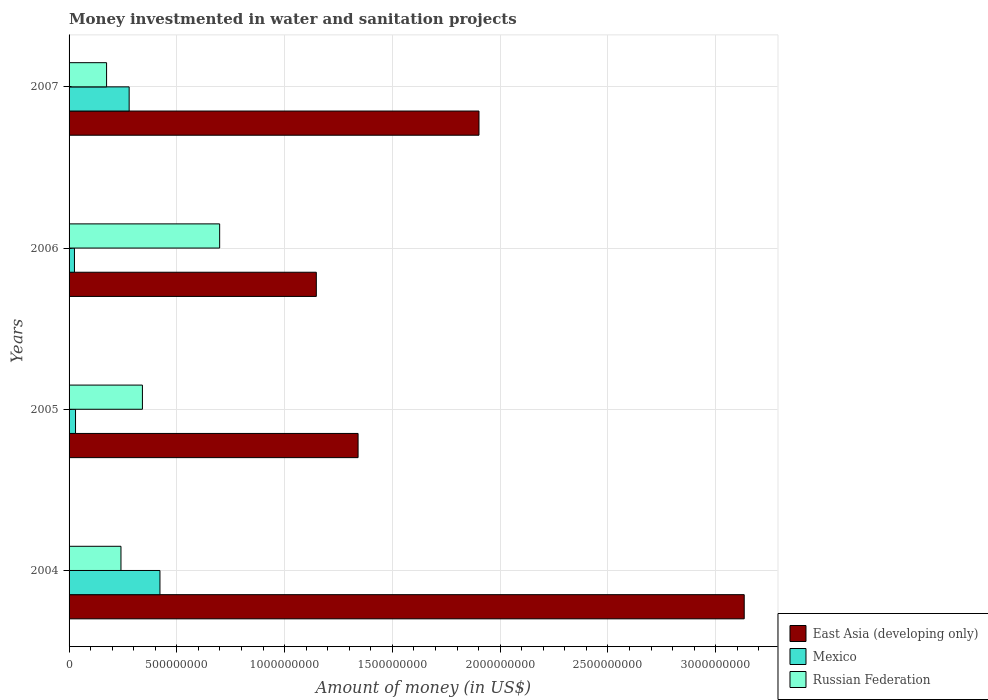How many different coloured bars are there?
Your answer should be very brief. 3. How many groups of bars are there?
Offer a very short reply. 4. How many bars are there on the 4th tick from the top?
Ensure brevity in your answer.  3. How many bars are there on the 1st tick from the bottom?
Your answer should be compact. 3. What is the money investmented in water and sanitation projects in East Asia (developing only) in 2005?
Offer a very short reply. 1.34e+09. Across all years, what is the maximum money investmented in water and sanitation projects in East Asia (developing only)?
Ensure brevity in your answer.  3.13e+09. Across all years, what is the minimum money investmented in water and sanitation projects in Mexico?
Your answer should be compact. 2.50e+07. In which year was the money investmented in water and sanitation projects in Russian Federation maximum?
Provide a succinct answer. 2006. What is the total money investmented in water and sanitation projects in Russian Federation in the graph?
Offer a very short reply. 1.45e+09. What is the difference between the money investmented in water and sanitation projects in East Asia (developing only) in 2004 and that in 2005?
Offer a very short reply. 1.79e+09. What is the difference between the money investmented in water and sanitation projects in Russian Federation in 2004 and the money investmented in water and sanitation projects in East Asia (developing only) in 2005?
Your response must be concise. -1.10e+09. What is the average money investmented in water and sanitation projects in East Asia (developing only) per year?
Provide a succinct answer. 1.88e+09. In the year 2005, what is the difference between the money investmented in water and sanitation projects in Russian Federation and money investmented in water and sanitation projects in Mexico?
Keep it short and to the point. 3.10e+08. In how many years, is the money investmented in water and sanitation projects in Mexico greater than 500000000 US$?
Offer a terse response. 0. What is the ratio of the money investmented in water and sanitation projects in East Asia (developing only) in 2005 to that in 2007?
Your response must be concise. 0.71. What is the difference between the highest and the second highest money investmented in water and sanitation projects in Mexico?
Your response must be concise. 1.43e+08. What is the difference between the highest and the lowest money investmented in water and sanitation projects in East Asia (developing only)?
Offer a very short reply. 1.99e+09. Is the sum of the money investmented in water and sanitation projects in Russian Federation in 2004 and 2007 greater than the maximum money investmented in water and sanitation projects in East Asia (developing only) across all years?
Provide a short and direct response. No. What does the 1st bar from the top in 2004 represents?
Ensure brevity in your answer.  Russian Federation. What does the 3rd bar from the bottom in 2004 represents?
Provide a succinct answer. Russian Federation. Are all the bars in the graph horizontal?
Provide a succinct answer. Yes. How many years are there in the graph?
Give a very brief answer. 4. What is the difference between two consecutive major ticks on the X-axis?
Ensure brevity in your answer.  5.00e+08. Does the graph contain any zero values?
Make the answer very short. No. Where does the legend appear in the graph?
Ensure brevity in your answer.  Bottom right. How many legend labels are there?
Make the answer very short. 3. What is the title of the graph?
Your response must be concise. Money investmented in water and sanitation projects. Does "Europe(all income levels)" appear as one of the legend labels in the graph?
Provide a succinct answer. No. What is the label or title of the X-axis?
Give a very brief answer. Amount of money (in US$). What is the label or title of the Y-axis?
Make the answer very short. Years. What is the Amount of money (in US$) of East Asia (developing only) in 2004?
Provide a short and direct response. 3.13e+09. What is the Amount of money (in US$) in Mexico in 2004?
Your response must be concise. 4.22e+08. What is the Amount of money (in US$) in Russian Federation in 2004?
Ensure brevity in your answer.  2.41e+08. What is the Amount of money (in US$) of East Asia (developing only) in 2005?
Keep it short and to the point. 1.34e+09. What is the Amount of money (in US$) of Mexico in 2005?
Provide a short and direct response. 3.00e+07. What is the Amount of money (in US$) in Russian Federation in 2005?
Your answer should be very brief. 3.40e+08. What is the Amount of money (in US$) of East Asia (developing only) in 2006?
Make the answer very short. 1.15e+09. What is the Amount of money (in US$) of Mexico in 2006?
Give a very brief answer. 2.50e+07. What is the Amount of money (in US$) of Russian Federation in 2006?
Your response must be concise. 6.99e+08. What is the Amount of money (in US$) in East Asia (developing only) in 2007?
Make the answer very short. 1.90e+09. What is the Amount of money (in US$) of Mexico in 2007?
Offer a terse response. 2.79e+08. What is the Amount of money (in US$) in Russian Federation in 2007?
Your answer should be very brief. 1.74e+08. Across all years, what is the maximum Amount of money (in US$) of East Asia (developing only)?
Your response must be concise. 3.13e+09. Across all years, what is the maximum Amount of money (in US$) in Mexico?
Provide a succinct answer. 4.22e+08. Across all years, what is the maximum Amount of money (in US$) in Russian Federation?
Give a very brief answer. 6.99e+08. Across all years, what is the minimum Amount of money (in US$) of East Asia (developing only)?
Your response must be concise. 1.15e+09. Across all years, what is the minimum Amount of money (in US$) in Mexico?
Make the answer very short. 2.50e+07. Across all years, what is the minimum Amount of money (in US$) of Russian Federation?
Offer a terse response. 1.74e+08. What is the total Amount of money (in US$) of East Asia (developing only) in the graph?
Your answer should be compact. 7.52e+09. What is the total Amount of money (in US$) in Mexico in the graph?
Give a very brief answer. 7.56e+08. What is the total Amount of money (in US$) of Russian Federation in the graph?
Provide a short and direct response. 1.45e+09. What is the difference between the Amount of money (in US$) of East Asia (developing only) in 2004 and that in 2005?
Make the answer very short. 1.79e+09. What is the difference between the Amount of money (in US$) of Mexico in 2004 and that in 2005?
Offer a terse response. 3.92e+08. What is the difference between the Amount of money (in US$) in Russian Federation in 2004 and that in 2005?
Your answer should be compact. -9.95e+07. What is the difference between the Amount of money (in US$) in East Asia (developing only) in 2004 and that in 2006?
Your answer should be compact. 1.99e+09. What is the difference between the Amount of money (in US$) of Mexico in 2004 and that in 2006?
Ensure brevity in your answer.  3.97e+08. What is the difference between the Amount of money (in US$) in Russian Federation in 2004 and that in 2006?
Make the answer very short. -4.58e+08. What is the difference between the Amount of money (in US$) in East Asia (developing only) in 2004 and that in 2007?
Your answer should be very brief. 1.23e+09. What is the difference between the Amount of money (in US$) in Mexico in 2004 and that in 2007?
Offer a terse response. 1.43e+08. What is the difference between the Amount of money (in US$) of Russian Federation in 2004 and that in 2007?
Offer a terse response. 6.68e+07. What is the difference between the Amount of money (in US$) in East Asia (developing only) in 2005 and that in 2006?
Keep it short and to the point. 1.94e+08. What is the difference between the Amount of money (in US$) in Russian Federation in 2005 and that in 2006?
Make the answer very short. -3.58e+08. What is the difference between the Amount of money (in US$) in East Asia (developing only) in 2005 and that in 2007?
Provide a short and direct response. -5.61e+08. What is the difference between the Amount of money (in US$) in Mexico in 2005 and that in 2007?
Offer a terse response. -2.49e+08. What is the difference between the Amount of money (in US$) of Russian Federation in 2005 and that in 2007?
Your answer should be compact. 1.66e+08. What is the difference between the Amount of money (in US$) in East Asia (developing only) in 2006 and that in 2007?
Your answer should be compact. -7.55e+08. What is the difference between the Amount of money (in US$) of Mexico in 2006 and that in 2007?
Your answer should be compact. -2.54e+08. What is the difference between the Amount of money (in US$) in Russian Federation in 2006 and that in 2007?
Keep it short and to the point. 5.25e+08. What is the difference between the Amount of money (in US$) in East Asia (developing only) in 2004 and the Amount of money (in US$) in Mexico in 2005?
Keep it short and to the point. 3.10e+09. What is the difference between the Amount of money (in US$) of East Asia (developing only) in 2004 and the Amount of money (in US$) of Russian Federation in 2005?
Offer a terse response. 2.79e+09. What is the difference between the Amount of money (in US$) in Mexico in 2004 and the Amount of money (in US$) in Russian Federation in 2005?
Provide a succinct answer. 8.14e+07. What is the difference between the Amount of money (in US$) of East Asia (developing only) in 2004 and the Amount of money (in US$) of Mexico in 2006?
Keep it short and to the point. 3.11e+09. What is the difference between the Amount of money (in US$) in East Asia (developing only) in 2004 and the Amount of money (in US$) in Russian Federation in 2006?
Your answer should be very brief. 2.43e+09. What is the difference between the Amount of money (in US$) of Mexico in 2004 and the Amount of money (in US$) of Russian Federation in 2006?
Give a very brief answer. -2.77e+08. What is the difference between the Amount of money (in US$) of East Asia (developing only) in 2004 and the Amount of money (in US$) of Mexico in 2007?
Give a very brief answer. 2.85e+09. What is the difference between the Amount of money (in US$) in East Asia (developing only) in 2004 and the Amount of money (in US$) in Russian Federation in 2007?
Ensure brevity in your answer.  2.96e+09. What is the difference between the Amount of money (in US$) of Mexico in 2004 and the Amount of money (in US$) of Russian Federation in 2007?
Provide a short and direct response. 2.48e+08. What is the difference between the Amount of money (in US$) in East Asia (developing only) in 2005 and the Amount of money (in US$) in Mexico in 2006?
Keep it short and to the point. 1.32e+09. What is the difference between the Amount of money (in US$) in East Asia (developing only) in 2005 and the Amount of money (in US$) in Russian Federation in 2006?
Provide a succinct answer. 6.42e+08. What is the difference between the Amount of money (in US$) of Mexico in 2005 and the Amount of money (in US$) of Russian Federation in 2006?
Your answer should be very brief. -6.69e+08. What is the difference between the Amount of money (in US$) in East Asia (developing only) in 2005 and the Amount of money (in US$) in Mexico in 2007?
Give a very brief answer. 1.06e+09. What is the difference between the Amount of money (in US$) of East Asia (developing only) in 2005 and the Amount of money (in US$) of Russian Federation in 2007?
Keep it short and to the point. 1.17e+09. What is the difference between the Amount of money (in US$) of Mexico in 2005 and the Amount of money (in US$) of Russian Federation in 2007?
Offer a terse response. -1.44e+08. What is the difference between the Amount of money (in US$) in East Asia (developing only) in 2006 and the Amount of money (in US$) in Mexico in 2007?
Ensure brevity in your answer.  8.68e+08. What is the difference between the Amount of money (in US$) of East Asia (developing only) in 2006 and the Amount of money (in US$) of Russian Federation in 2007?
Your answer should be compact. 9.73e+08. What is the difference between the Amount of money (in US$) of Mexico in 2006 and the Amount of money (in US$) of Russian Federation in 2007?
Ensure brevity in your answer.  -1.49e+08. What is the average Amount of money (in US$) in East Asia (developing only) per year?
Offer a terse response. 1.88e+09. What is the average Amount of money (in US$) of Mexico per year?
Provide a short and direct response. 1.89e+08. What is the average Amount of money (in US$) of Russian Federation per year?
Provide a short and direct response. 3.63e+08. In the year 2004, what is the difference between the Amount of money (in US$) of East Asia (developing only) and Amount of money (in US$) of Mexico?
Give a very brief answer. 2.71e+09. In the year 2004, what is the difference between the Amount of money (in US$) of East Asia (developing only) and Amount of money (in US$) of Russian Federation?
Offer a terse response. 2.89e+09. In the year 2004, what is the difference between the Amount of money (in US$) of Mexico and Amount of money (in US$) of Russian Federation?
Provide a succinct answer. 1.81e+08. In the year 2005, what is the difference between the Amount of money (in US$) in East Asia (developing only) and Amount of money (in US$) in Mexico?
Provide a short and direct response. 1.31e+09. In the year 2005, what is the difference between the Amount of money (in US$) of East Asia (developing only) and Amount of money (in US$) of Russian Federation?
Your response must be concise. 1.00e+09. In the year 2005, what is the difference between the Amount of money (in US$) in Mexico and Amount of money (in US$) in Russian Federation?
Provide a succinct answer. -3.10e+08. In the year 2006, what is the difference between the Amount of money (in US$) in East Asia (developing only) and Amount of money (in US$) in Mexico?
Your answer should be very brief. 1.12e+09. In the year 2006, what is the difference between the Amount of money (in US$) of East Asia (developing only) and Amount of money (in US$) of Russian Federation?
Provide a short and direct response. 4.48e+08. In the year 2006, what is the difference between the Amount of money (in US$) of Mexico and Amount of money (in US$) of Russian Federation?
Offer a very short reply. -6.74e+08. In the year 2007, what is the difference between the Amount of money (in US$) of East Asia (developing only) and Amount of money (in US$) of Mexico?
Offer a terse response. 1.62e+09. In the year 2007, what is the difference between the Amount of money (in US$) in East Asia (developing only) and Amount of money (in US$) in Russian Federation?
Make the answer very short. 1.73e+09. In the year 2007, what is the difference between the Amount of money (in US$) of Mexico and Amount of money (in US$) of Russian Federation?
Your answer should be very brief. 1.05e+08. What is the ratio of the Amount of money (in US$) in East Asia (developing only) in 2004 to that in 2005?
Give a very brief answer. 2.34. What is the ratio of the Amount of money (in US$) of Mexico in 2004 to that in 2005?
Make the answer very short. 14.06. What is the ratio of the Amount of money (in US$) in Russian Federation in 2004 to that in 2005?
Provide a succinct answer. 0.71. What is the ratio of the Amount of money (in US$) of East Asia (developing only) in 2004 to that in 2006?
Provide a succinct answer. 2.73. What is the ratio of the Amount of money (in US$) in Mexico in 2004 to that in 2006?
Offer a very short reply. 16.87. What is the ratio of the Amount of money (in US$) of Russian Federation in 2004 to that in 2006?
Your response must be concise. 0.34. What is the ratio of the Amount of money (in US$) of East Asia (developing only) in 2004 to that in 2007?
Offer a very short reply. 1.65. What is the ratio of the Amount of money (in US$) in Mexico in 2004 to that in 2007?
Your answer should be very brief. 1.51. What is the ratio of the Amount of money (in US$) in Russian Federation in 2004 to that in 2007?
Keep it short and to the point. 1.38. What is the ratio of the Amount of money (in US$) in East Asia (developing only) in 2005 to that in 2006?
Make the answer very short. 1.17. What is the ratio of the Amount of money (in US$) in Russian Federation in 2005 to that in 2006?
Ensure brevity in your answer.  0.49. What is the ratio of the Amount of money (in US$) in East Asia (developing only) in 2005 to that in 2007?
Your answer should be very brief. 0.71. What is the ratio of the Amount of money (in US$) in Mexico in 2005 to that in 2007?
Offer a very short reply. 0.11. What is the ratio of the Amount of money (in US$) in Russian Federation in 2005 to that in 2007?
Make the answer very short. 1.96. What is the ratio of the Amount of money (in US$) in East Asia (developing only) in 2006 to that in 2007?
Make the answer very short. 0.6. What is the ratio of the Amount of money (in US$) of Mexico in 2006 to that in 2007?
Your answer should be very brief. 0.09. What is the ratio of the Amount of money (in US$) of Russian Federation in 2006 to that in 2007?
Offer a very short reply. 4.02. What is the difference between the highest and the second highest Amount of money (in US$) in East Asia (developing only)?
Your response must be concise. 1.23e+09. What is the difference between the highest and the second highest Amount of money (in US$) of Mexico?
Offer a terse response. 1.43e+08. What is the difference between the highest and the second highest Amount of money (in US$) in Russian Federation?
Make the answer very short. 3.58e+08. What is the difference between the highest and the lowest Amount of money (in US$) of East Asia (developing only)?
Provide a short and direct response. 1.99e+09. What is the difference between the highest and the lowest Amount of money (in US$) in Mexico?
Ensure brevity in your answer.  3.97e+08. What is the difference between the highest and the lowest Amount of money (in US$) in Russian Federation?
Ensure brevity in your answer.  5.25e+08. 